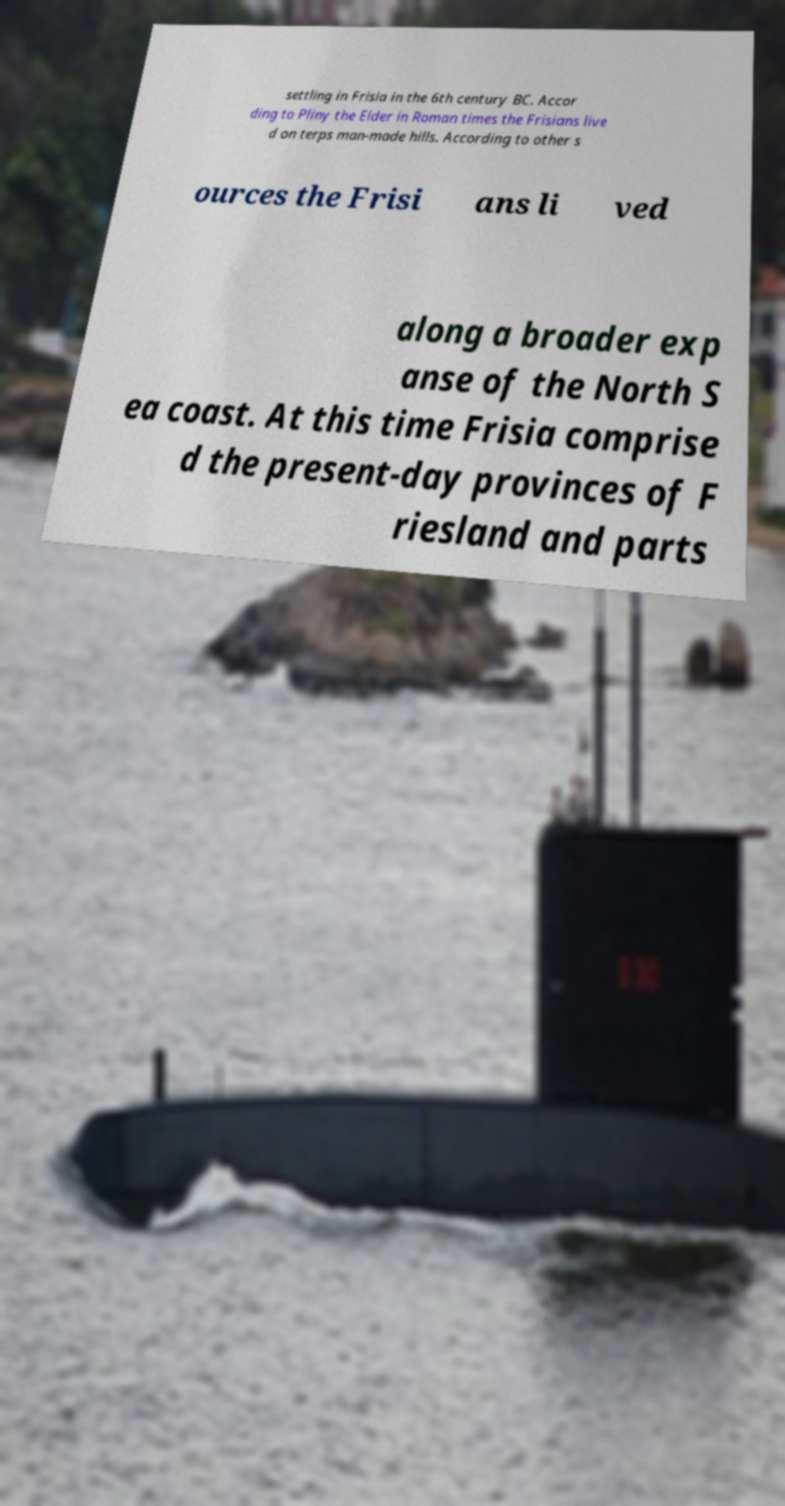Can you accurately transcribe the text from the provided image for me? settling in Frisia in the 6th century BC. Accor ding to Pliny the Elder in Roman times the Frisians live d on terps man-made hills. According to other s ources the Frisi ans li ved along a broader exp anse of the North S ea coast. At this time Frisia comprise d the present-day provinces of F riesland and parts 